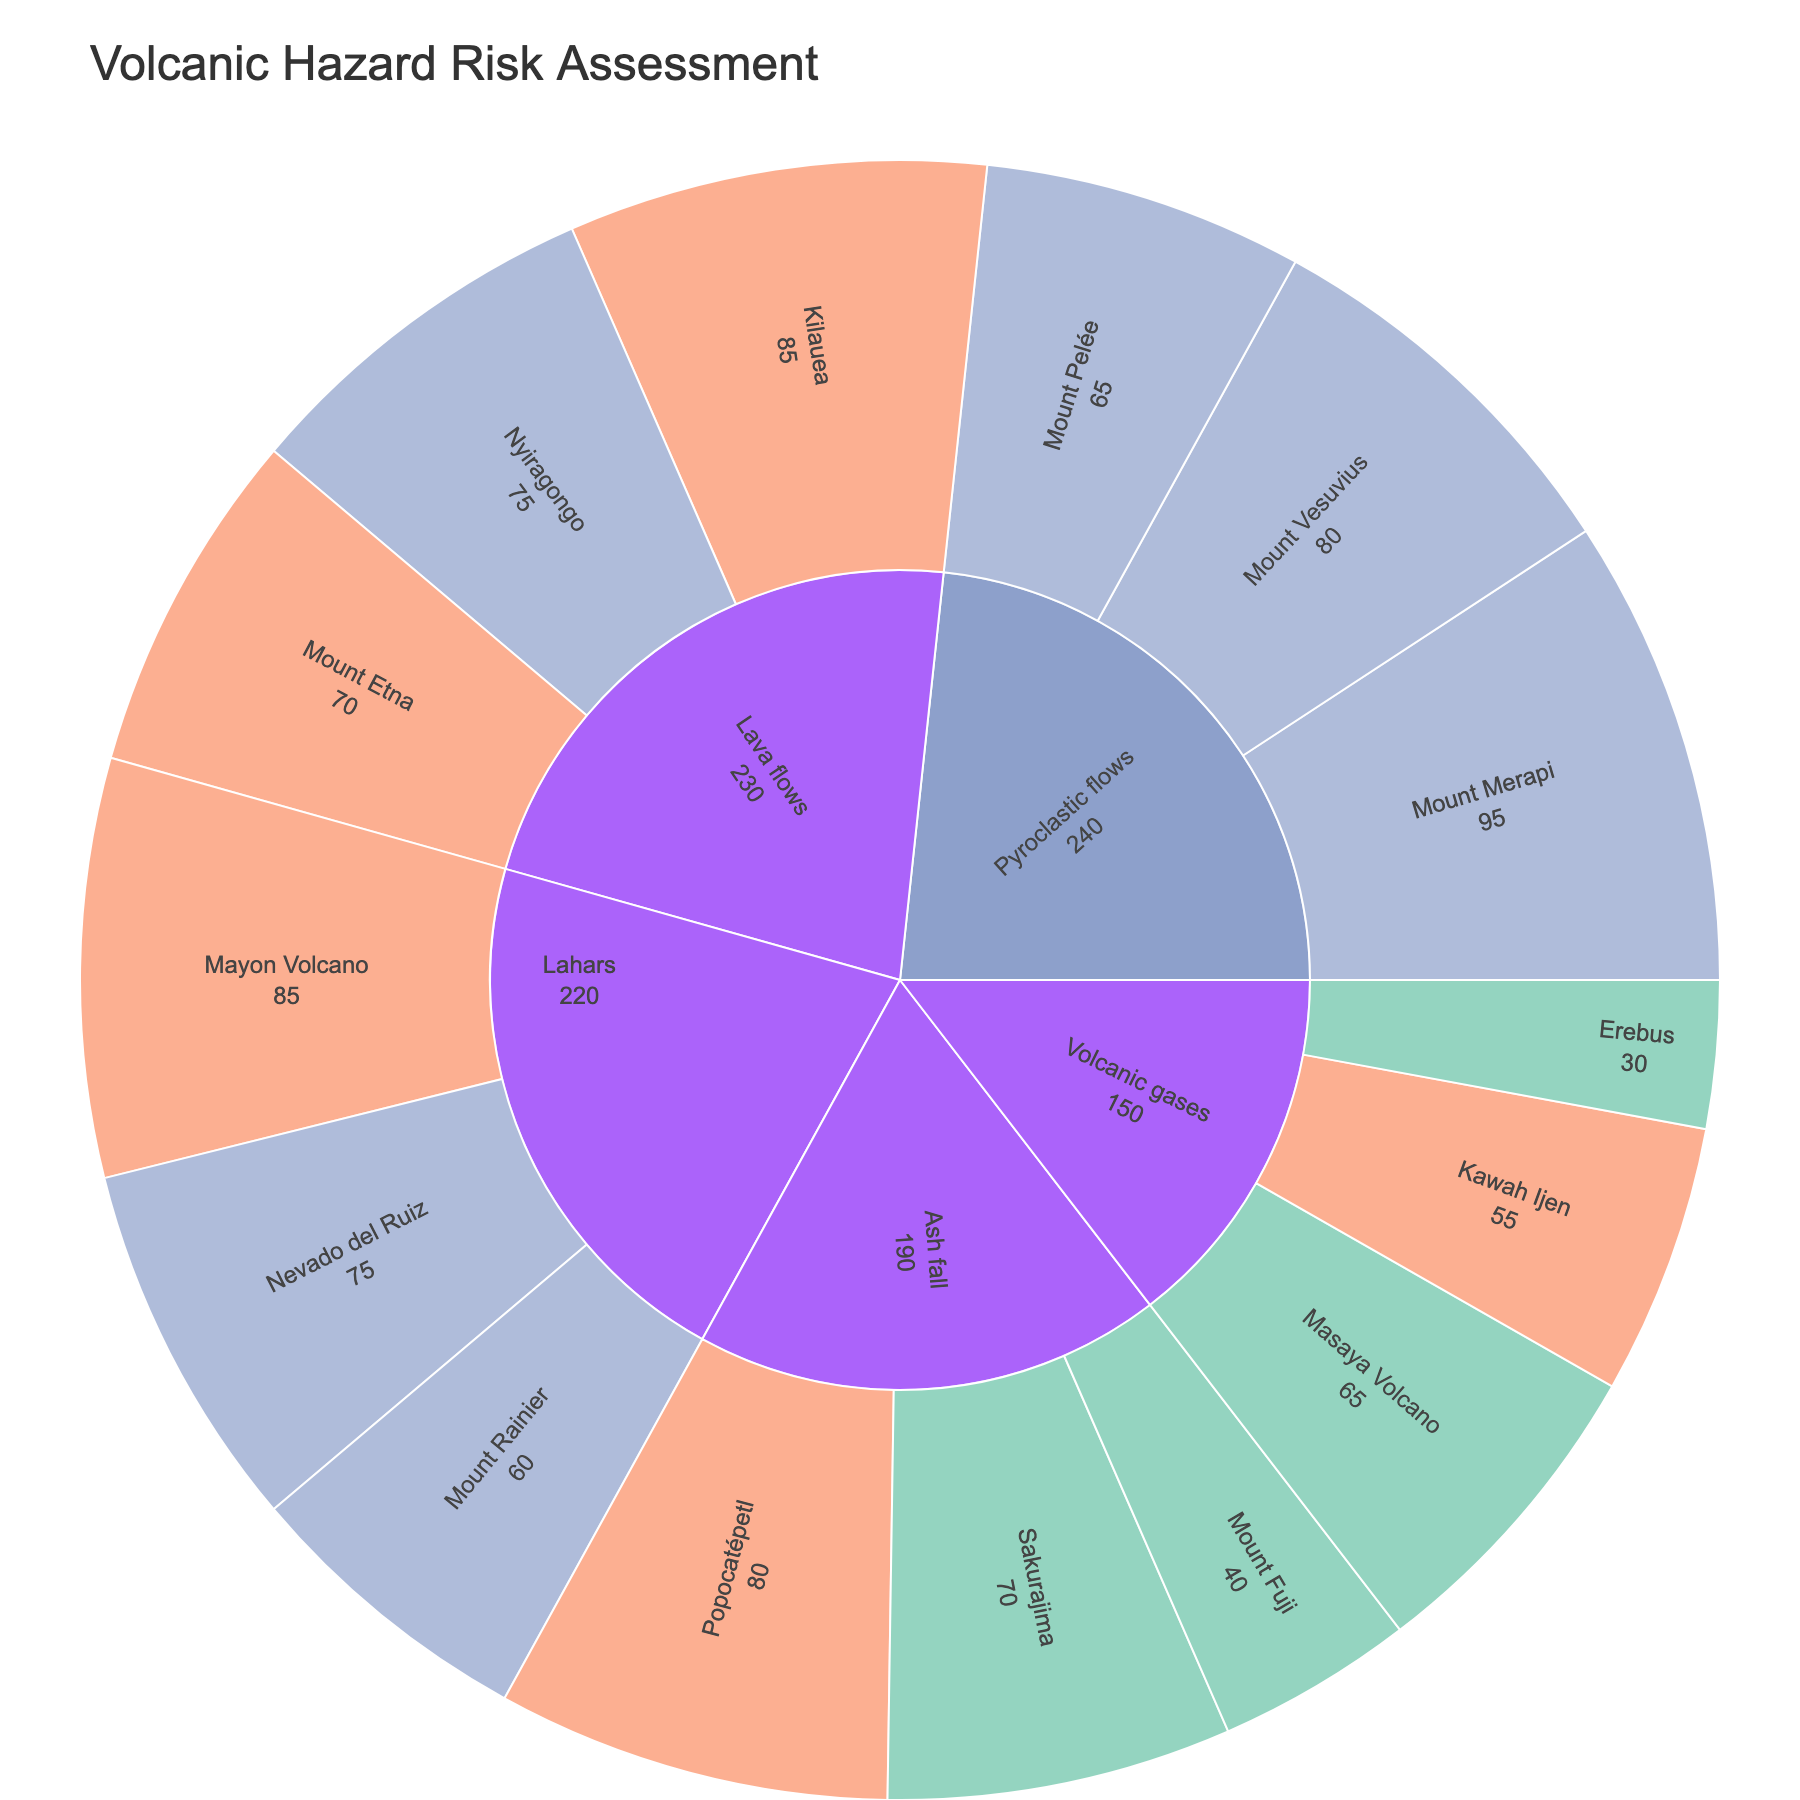What is the impact level with the color '#8da0cb'? The color '#8da0cb' is used in the color_discrete_map to represent the 'High' impact level in the sunburst plot.
Answer: High Which volcano has the highest risk value for Pyroclastic flows? From the sunburst plot, under the Pyroclastic flows category, the volcano with the highest risk value is Mount Merapi with a value of 95.
Answer: Mount Merapi What is the total risk value for all volcanoes in the Lava flows category? Sum the risk values for each volcano under the Lava flows category: Kilauea (85) + Mount Etna (70) + Nyiragongo (75) = 230.
Answer: 230 Which hazard category has the lowest overall risk value? Compare the total risk values of each hazard category: Pyroclastic flows (240), Lava flows (230), Ash fall (190), Lahars (220), Volcanic gases (150). The category with the lowest overall risk value is Volcanic gases.
Answer: Volcanic gases What is the ratio of the risk value of Mount Rainier's Lahars to Mount Pelée's Pyroclastic flows? The risk value of Mount Rainier's Lahars is 60, and Mount Pelée's Pyroclastic flows is 65. The ratio is 60/65, which simplifies to 0.92.
Answer: 0.92 Which volcano has the highest probability of an eruption in the Ash fall category? Under the Ash fall category, the volcanoes are Mount Fuji (Low), Popocatépetl (High), and Sakurajima (High). Both Popocatépetl and Sakurajima have High probability, but no distinction is made between them in the provided data.
Answer: Popocatépetl or Sakurajima What's the average risk value for volcanoes with a Medium probability? The volcanoes with Medium probability are Mount Vesuvius (80), Mount Etna (70), Nyiragongo (75), Nevado del Ruiz (75), and Kawah Ijen (55). Sum these values: 80 + 70 + 75 + 75 + 55 = 355, and the average is 355/5 = 71.
Answer: 71 Which hazard category has the highest number of volcanoes with a High impact level? Check the number of volcanoes with 'High' impact in each category: Pyroclastic flows (3), Lava flows (1), Ash fall (0), Lahars (2), Volcanic gases (0). The category with the highest number is Pyroclastic flows.
Answer: Pyroclastic flows What is the combined risk value for volcanoes under the Volcanic gases category with a probability labeled as High? Only Masaya Volcano has a High probability in the Volcanic gases category with a risk value of 65.
Answer: 65 